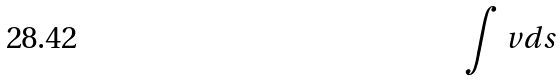Convert formula to latex. <formula><loc_0><loc_0><loc_500><loc_500>\int v d s</formula> 